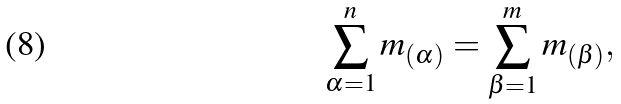<formula> <loc_0><loc_0><loc_500><loc_500>\sum _ { \alpha = 1 } ^ { n } m _ { ( \alpha ) } = \sum _ { \beta = 1 } ^ { m } m _ { ( \beta ) } ,</formula> 